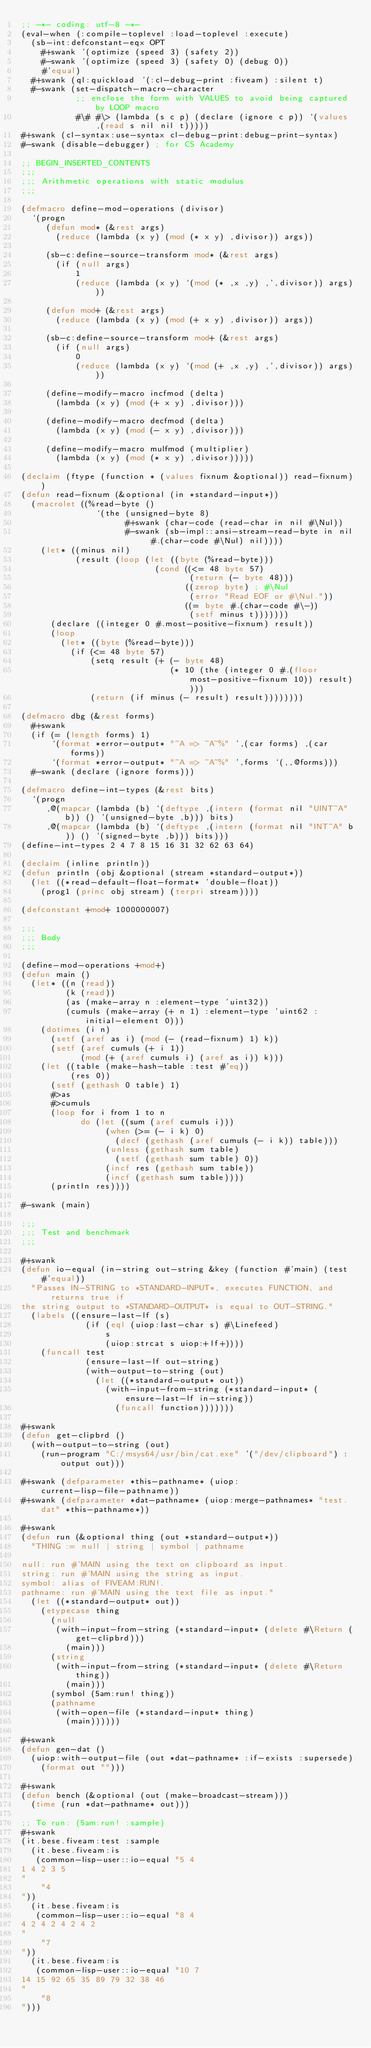<code> <loc_0><loc_0><loc_500><loc_500><_Lisp_>;; -*- coding: utf-8 -*-
(eval-when (:compile-toplevel :load-toplevel :execute)
  (sb-int:defconstant-eqx OPT
    #+swank '(optimize (speed 3) (safety 2))
    #-swank '(optimize (speed 3) (safety 0) (debug 0))
    #'equal)
  #+swank (ql:quickload '(:cl-debug-print :fiveam) :silent t)
  #-swank (set-dispatch-macro-character
           ;; enclose the form with VALUES to avoid being captured by LOOP macro
           #\# #\> (lambda (s c p) (declare (ignore c p)) `(values ,(read s nil nil t)))))
#+swank (cl-syntax:use-syntax cl-debug-print:debug-print-syntax)
#-swank (disable-debugger) ; for CS Academy

;; BEGIN_INSERTED_CONTENTS
;;;
;;; Arithmetic operations with static modulus
;;;

(defmacro define-mod-operations (divisor)
  `(progn
     (defun mod* (&rest args)
       (reduce (lambda (x y) (mod (* x y) ,divisor)) args))

     (sb-c:define-source-transform mod* (&rest args)
       (if (null args)
           1
           (reduce (lambda (x y) `(mod (* ,x ,y) ,',divisor)) args)))

     (defun mod+ (&rest args)
       (reduce (lambda (x y) (mod (+ x y) ,divisor)) args))

     (sb-c:define-source-transform mod+ (&rest args)
       (if (null args)
           0
           (reduce (lambda (x y) `(mod (+ ,x ,y) ,',divisor)) args)))

     (define-modify-macro incfmod (delta)
       (lambda (x y) (mod (+ x y) ,divisor)))

     (define-modify-macro decfmod (delta)
       (lambda (x y) (mod (- x y) ,divisor)))

     (define-modify-macro mulfmod (multiplier)
       (lambda (x y) (mod (* x y) ,divisor)))))

(declaim (ftype (function * (values fixnum &optional)) read-fixnum))
(defun read-fixnum (&optional (in *standard-input*))
  (macrolet ((%read-byte ()
               `(the (unsigned-byte 8)
                     #+swank (char-code (read-char in nil #\Nul))
                     #-swank (sb-impl::ansi-stream-read-byte in nil #.(char-code #\Nul) nil))))
    (let* ((minus nil)
           (result (loop (let ((byte (%read-byte)))
                           (cond ((<= 48 byte 57)
                                  (return (- byte 48)))
                                 ((zerop byte) ; #\Nul
                                  (error "Read EOF or #\Nul."))
                                 ((= byte #.(char-code #\-))
                                  (setf minus t)))))))
      (declare ((integer 0 #.most-positive-fixnum) result))
      (loop
        (let* ((byte (%read-byte)))
          (if (<= 48 byte 57)
              (setq result (+ (- byte 48)
                              (* 10 (the (integer 0 #.(floor most-positive-fixnum 10)) result))))
              (return (if minus (- result) result))))))))

(defmacro dbg (&rest forms)
  #+swank
  (if (= (length forms) 1)
      `(format *error-output* "~A => ~A~%" ',(car forms) ,(car forms))
      `(format *error-output* "~A => ~A~%" ',forms `(,,@forms)))
  #-swank (declare (ignore forms)))

(defmacro define-int-types (&rest bits)
  `(progn
     ,@(mapcar (lambda (b) `(deftype ,(intern (format nil "UINT~A" b)) () '(unsigned-byte ,b))) bits)
     ,@(mapcar (lambda (b) `(deftype ,(intern (format nil "INT~A" b)) () '(signed-byte ,b))) bits)))
(define-int-types 2 4 7 8 15 16 31 32 62 63 64)

(declaim (inline println))
(defun println (obj &optional (stream *standard-output*))
  (let ((*read-default-float-format* 'double-float))
    (prog1 (princ obj stream) (terpri stream))))

(defconstant +mod+ 1000000007)

;;;
;;; Body
;;;

(define-mod-operations +mod+)
(defun main ()
  (let* ((n (read))
         (k (read))
         (as (make-array n :element-type 'uint32))
         (cumuls (make-array (+ n 1) :element-type 'uint62 :initial-element 0)))
    (dotimes (i n)
      (setf (aref as i) (mod (- (read-fixnum) 1) k))
      (setf (aref cumuls (+ i 1))
            (mod (+ (aref cumuls i) (aref as i)) k)))
    (let ((table (make-hash-table :test #'eq))
          (res 0))
      (setf (gethash 0 table) 1)
      #>as
      #>cumuls
      (loop for i from 1 to n
            do (let ((sum (aref cumuls i)))
                 (when (>= (- i k) 0)
                   (decf (gethash (aref cumuls (- i k)) table)))
                 (unless (gethash sum table)
                   (setf (gethash sum table) 0))
                 (incf res (gethash sum table))
                 (incf (gethash sum table))))
      (println res))))

#-swank (main)

;;;
;;; Test and benchmark
;;;

#+swank
(defun io-equal (in-string out-string &key (function #'main) (test #'equal))
  "Passes IN-STRING to *STANDARD-INPUT*, executes FUNCTION, and returns true if
the string output to *STANDARD-OUTPUT* is equal to OUT-STRING."
  (labels ((ensure-last-lf (s)
             (if (eql (uiop:last-char s) #\Linefeed)
                 s
                 (uiop:strcat s uiop:+lf+))))
    (funcall test
             (ensure-last-lf out-string)
             (with-output-to-string (out)
               (let ((*standard-output* out))
                 (with-input-from-string (*standard-input* (ensure-last-lf in-string))
                   (funcall function)))))))

#+swank
(defun get-clipbrd ()
  (with-output-to-string (out)
    (run-program "C:/msys64/usr/bin/cat.exe" '("/dev/clipboard") :output out)))

#+swank (defparameter *this-pathname* (uiop:current-lisp-file-pathname))
#+swank (defparameter *dat-pathname* (uiop:merge-pathnames* "test.dat" *this-pathname*))

#+swank
(defun run (&optional thing (out *standard-output*))
  "THING := null | string | symbol | pathname

null: run #'MAIN using the text on clipboard as input.
string: run #'MAIN using the string as input.
symbol: alias of FIVEAM:RUN!.
pathname: run #'MAIN using the text file as input."
  (let ((*standard-output* out))
    (etypecase thing
      (null
       (with-input-from-string (*standard-input* (delete #\Return (get-clipbrd)))
         (main)))
      (string
       (with-input-from-string (*standard-input* (delete #\Return thing))
         (main)))
      (symbol (5am:run! thing))
      (pathname
       (with-open-file (*standard-input* thing)
         (main))))))

#+swank
(defun gen-dat ()
  (uiop:with-output-file (out *dat-pathname* :if-exists :supersede)
    (format out "")))

#+swank
(defun bench (&optional (out (make-broadcast-stream)))
  (time (run *dat-pathname* out)))

;; To run: (5am:run! :sample)
#+swank
(it.bese.fiveam:test :sample
  (it.bese.fiveam:is
   (common-lisp-user::io-equal "5 4
1 4 2 3 5
"
    "4
"))
  (it.bese.fiveam:is
   (common-lisp-user::io-equal "8 4
4 2 4 2 4 2 4 2
"
    "7
"))
  (it.bese.fiveam:is
   (common-lisp-user::io-equal "10 7
14 15 92 65 35 89 79 32 38 46
"
    "8
")))
</code> 